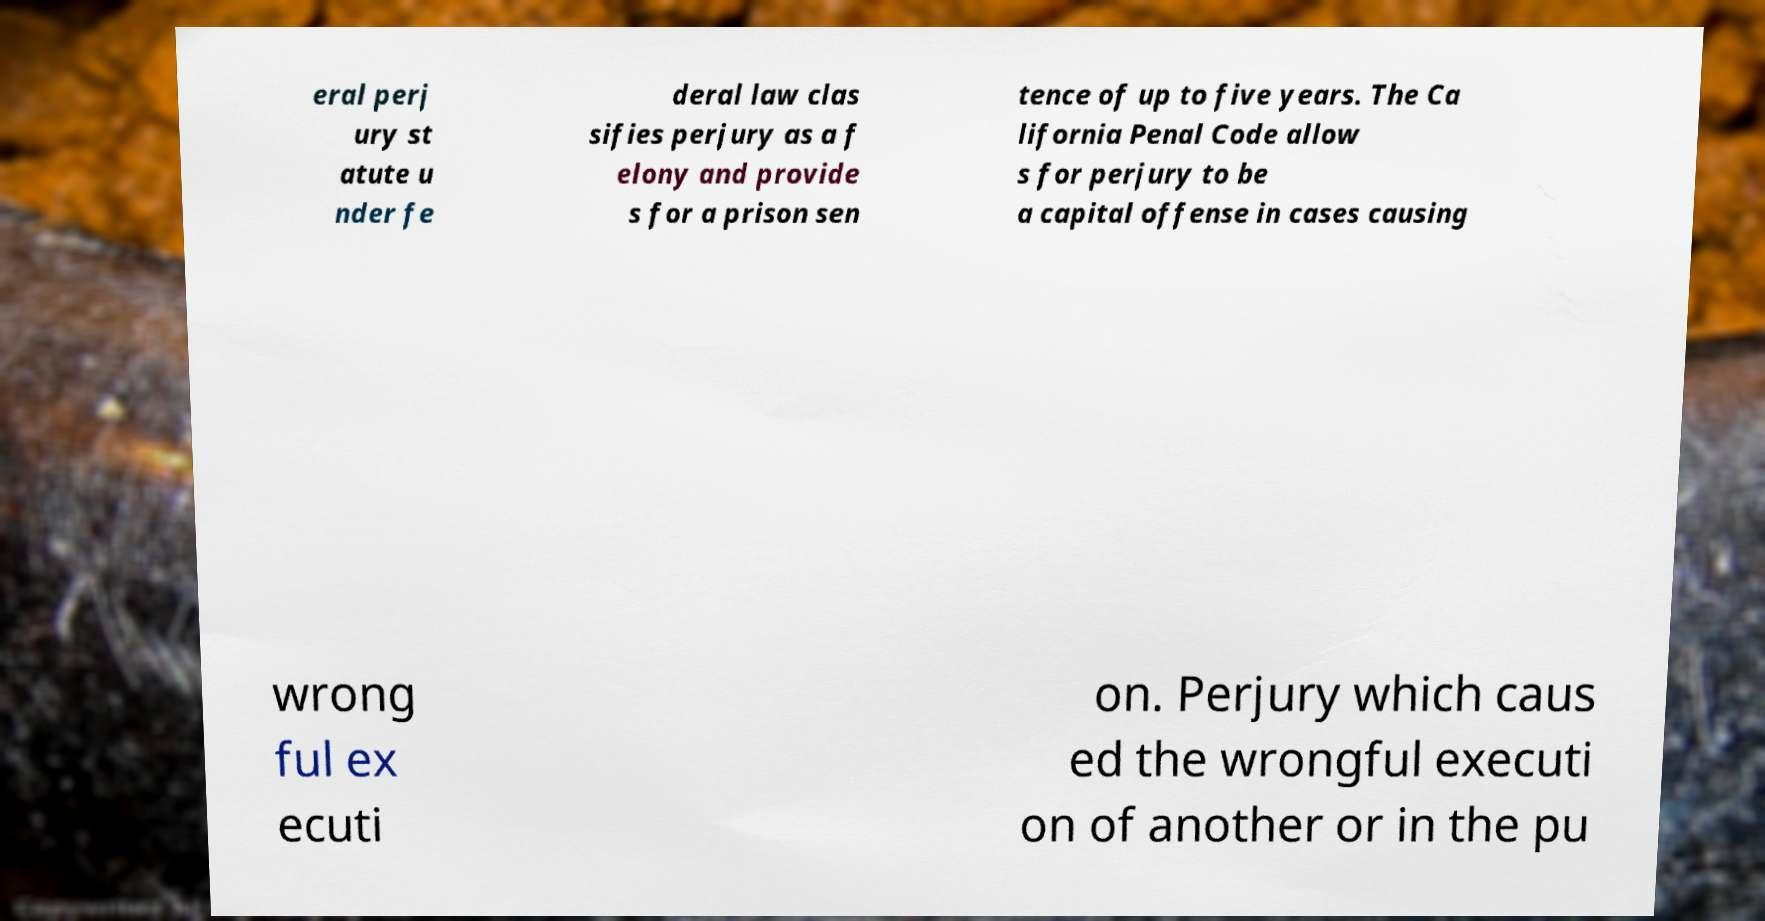Could you extract and type out the text from this image? eral perj ury st atute u nder fe deral law clas sifies perjury as a f elony and provide s for a prison sen tence of up to five years. The Ca lifornia Penal Code allow s for perjury to be a capital offense in cases causing wrong ful ex ecuti on. Perjury which caus ed the wrongful executi on of another or in the pu 